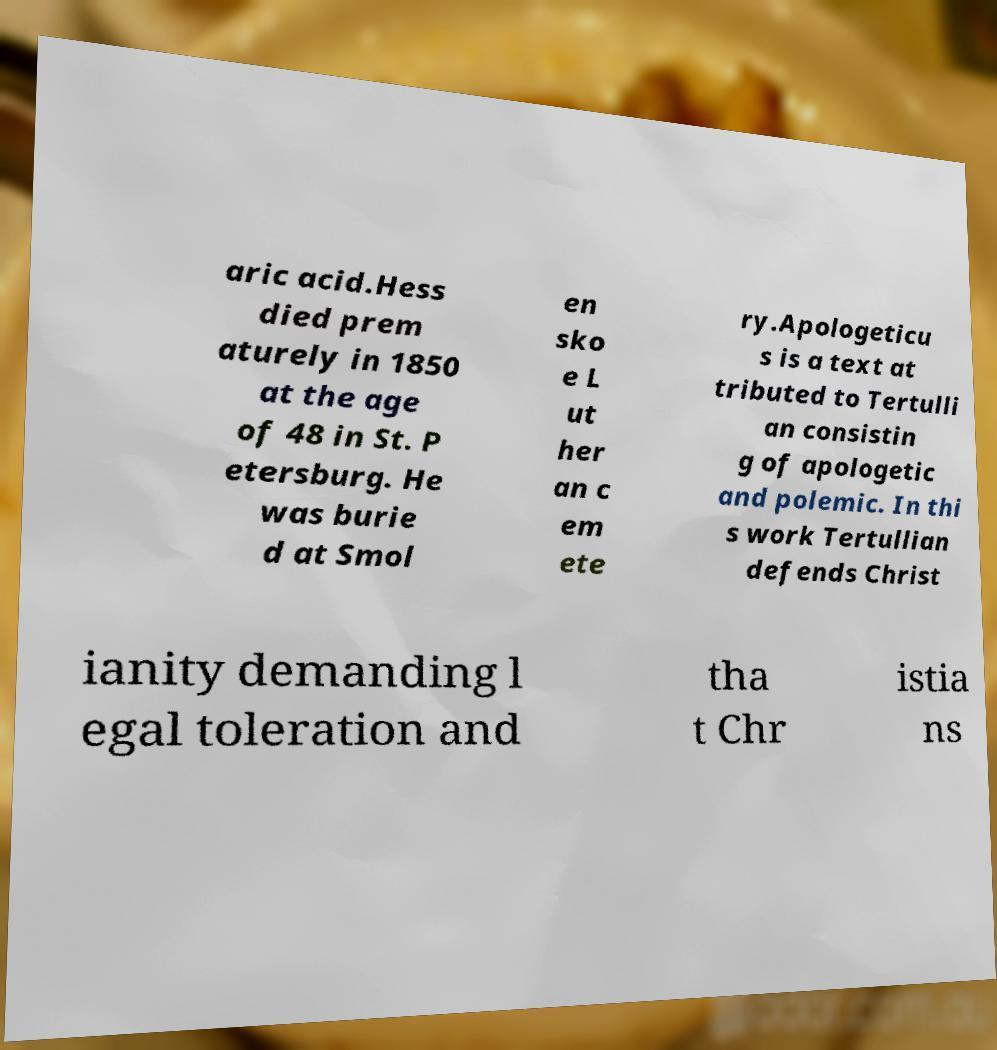I need the written content from this picture converted into text. Can you do that? aric acid.Hess died prem aturely in 1850 at the age of 48 in St. P etersburg. He was burie d at Smol en sko e L ut her an c em ete ry.Apologeticu s is a text at tributed to Tertulli an consistin g of apologetic and polemic. In thi s work Tertullian defends Christ ianity demanding l egal toleration and tha t Chr istia ns 